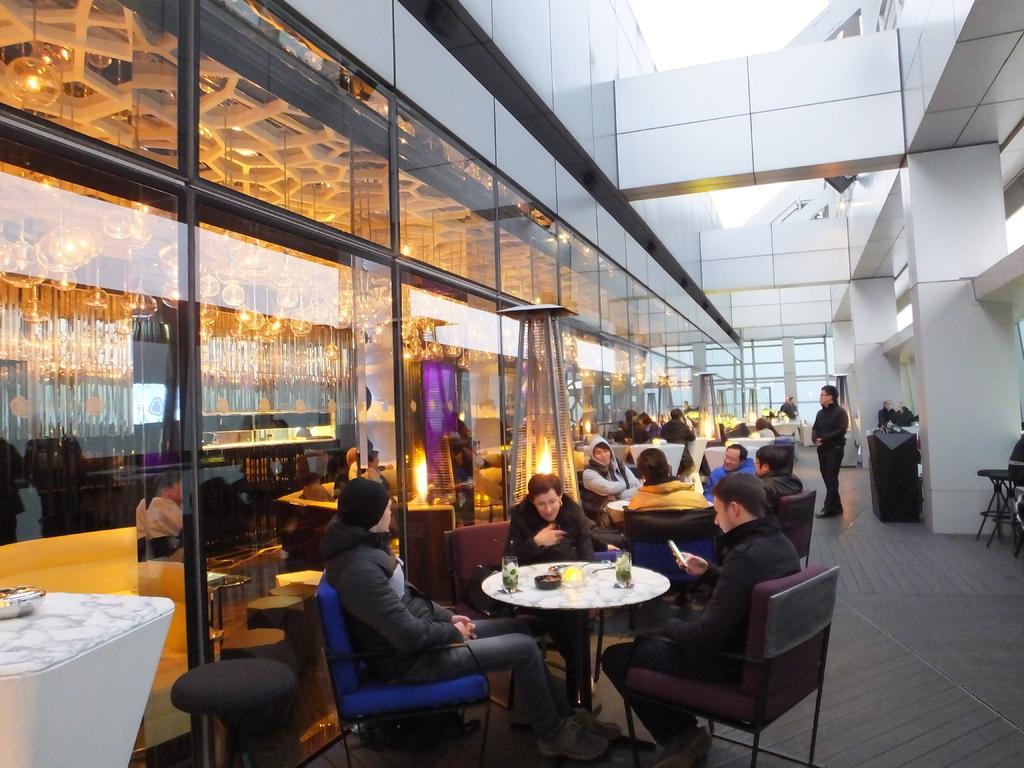What are the people in the image doing? The people in the image are sitting on chairs. What objects are present in the image besides the chairs? There are tables in the image. What can be seen on the tables? There are glasses on the tables in the image. Can you see any fish swimming in the image? There are no fish present in the image. What thoughts or ideas are the people in the image discussing? The image does not provide any information about the thoughts or ideas of the people in the image. 